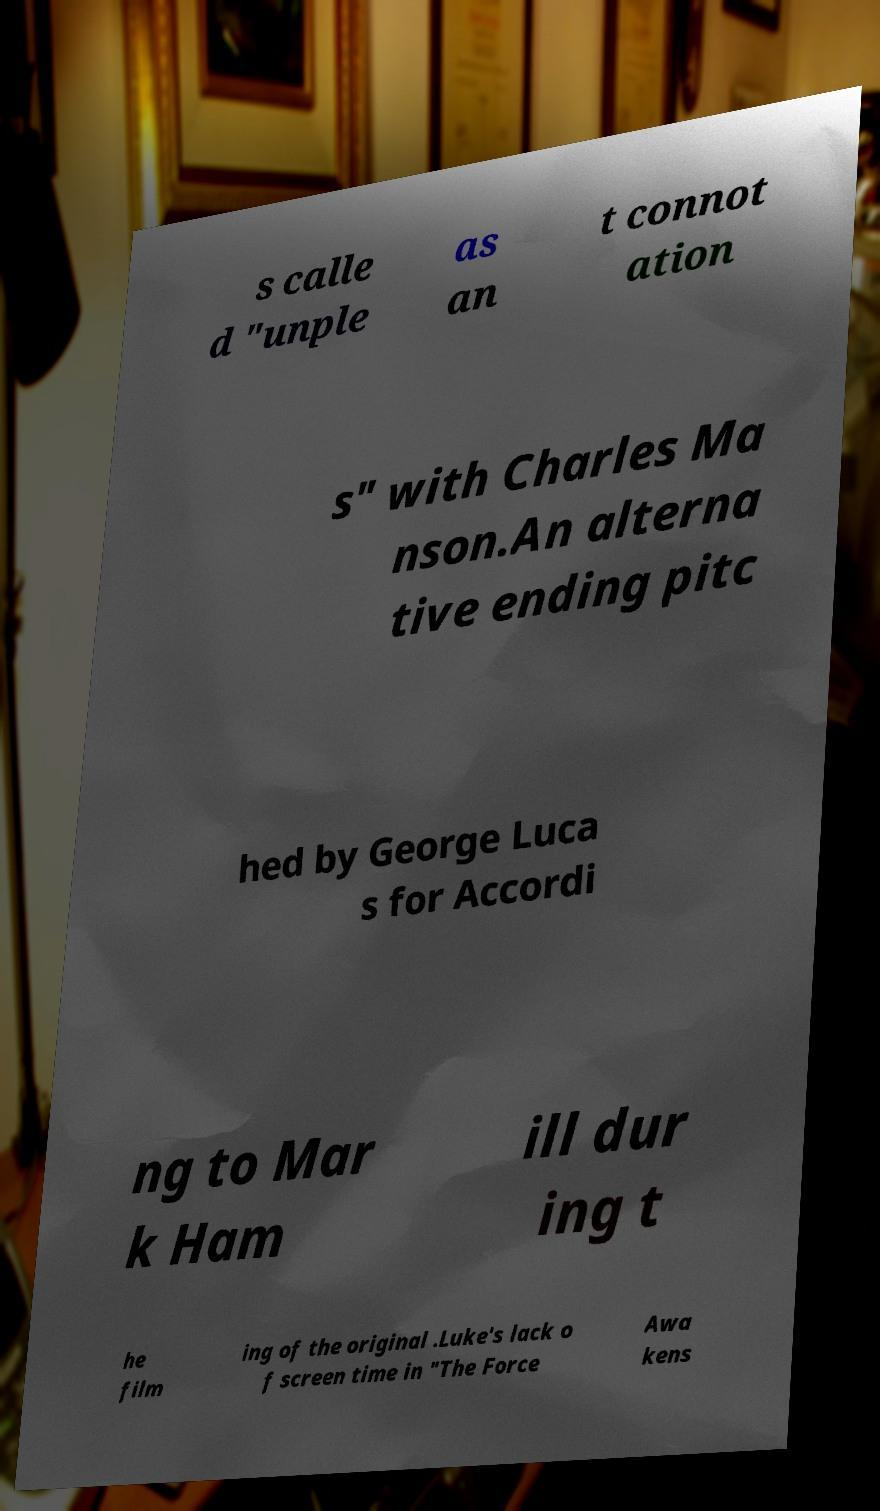What messages or text are displayed in this image? I need them in a readable, typed format. s calle d "unple as an t connot ation s" with Charles Ma nson.An alterna tive ending pitc hed by George Luca s for Accordi ng to Mar k Ham ill dur ing t he film ing of the original .Luke's lack o f screen time in "The Force Awa kens 